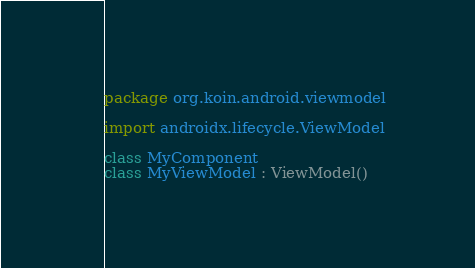Convert code to text. <code><loc_0><loc_0><loc_500><loc_500><_Kotlin_>package org.koin.android.viewmodel

import androidx.lifecycle.ViewModel

class MyComponent
class MyViewModel : ViewModel()
</code> 